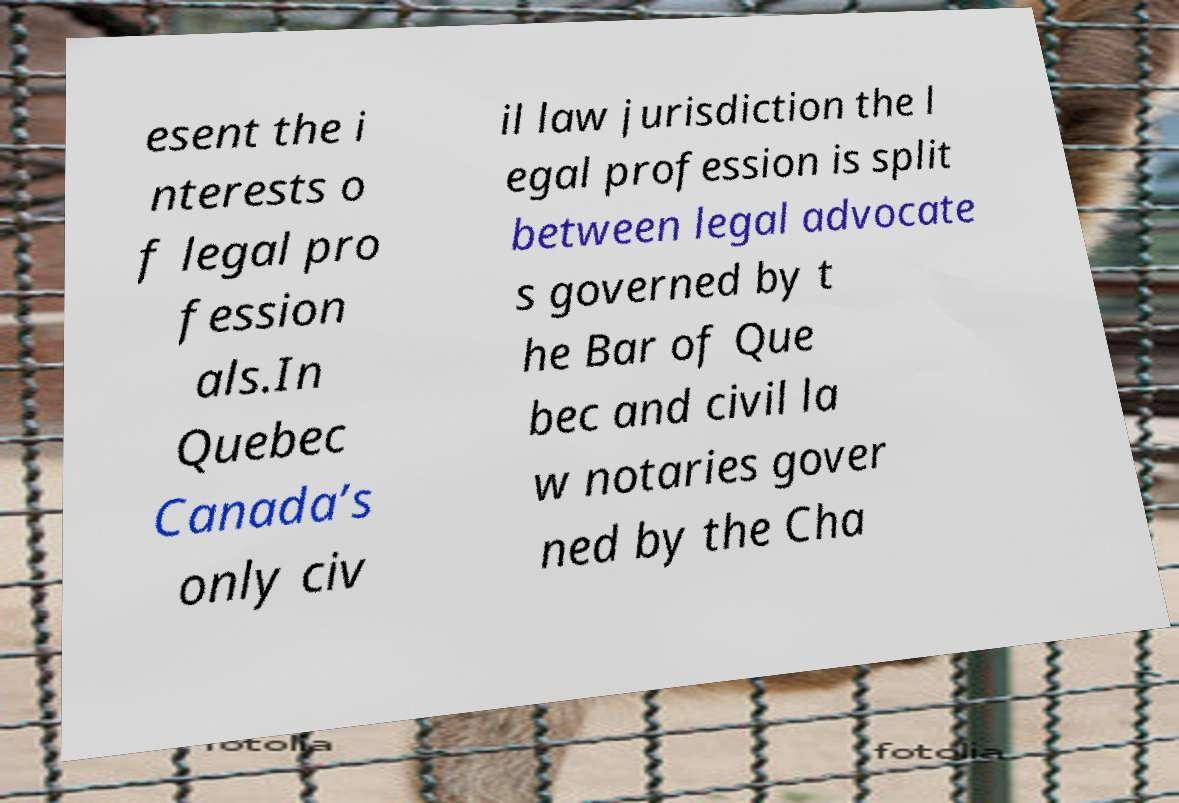Please read and relay the text visible in this image. What does it say? esent the i nterests o f legal pro fession als.In Quebec Canada’s only civ il law jurisdiction the l egal profession is split between legal advocate s governed by t he Bar of Que bec and civil la w notaries gover ned by the Cha 